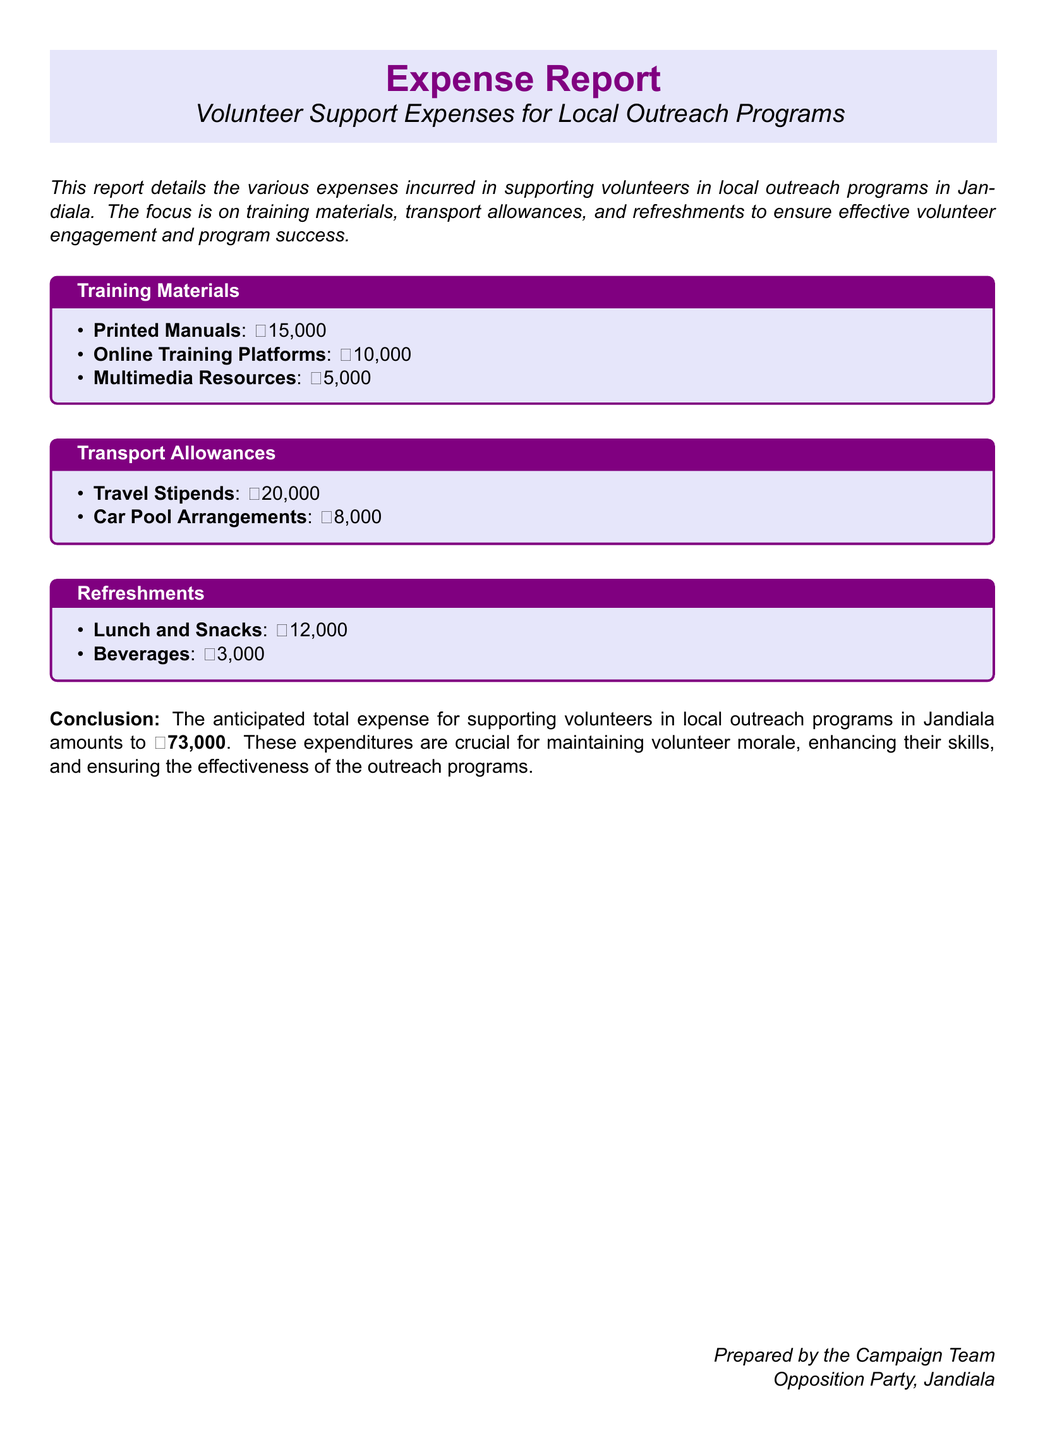What is the total amount spent on training materials? The total amount spent on training materials is the sum of the individual expenses listed under that category: 15,000 + 10,000 + 5,000 = 30,000.
Answer: ₹30,000 How much was allocated for transport allowances? The allocated amount for transport allowances is specifically itemized in the document: 20,000 + 8,000 = 28,000.
Answer: ₹28,000 What was the cost of lunch and snacks? The cost of lunch and snacks is directly provided in the refreshments section of the document.
Answer: ₹12,000 What is the total expense for the outreach programs? The total expense is stated clearly at the end of the document, which adds up all relevant costs.
Answer: ₹73,000 Which category has the highest individual expense? The category with the highest individual expense can be determined by comparing each item listed. Printed manuals is the highest.
Answer: Printed Manuals Are beverages included in the refreshments section? The refreshments section directly lists all items included, confirming the presence of beverages.
Answer: Yes What amount was spent on online training platforms? The online training platforms expense is detailed in the training materials section, providing an exact figure.
Answer: ₹10,000 How much was spent on car pool arrangements? The car pool arrangements expense can be found in the transport allowances section.
Answer: ₹8,000 Which organization prepared this expense report? The document specifies the organization responsible for preparing the report in the footer.
Answer: Opposition Party, Jandiala 